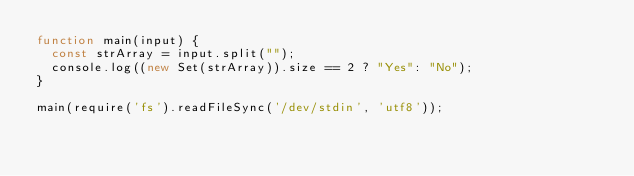<code> <loc_0><loc_0><loc_500><loc_500><_JavaScript_>function main(input) {
  const strArray = input.split("");
  console.log((new Set(strArray)).size == 2 ? "Yes": "No");
}

main(require('fs').readFileSync('/dev/stdin', 'utf8'));</code> 